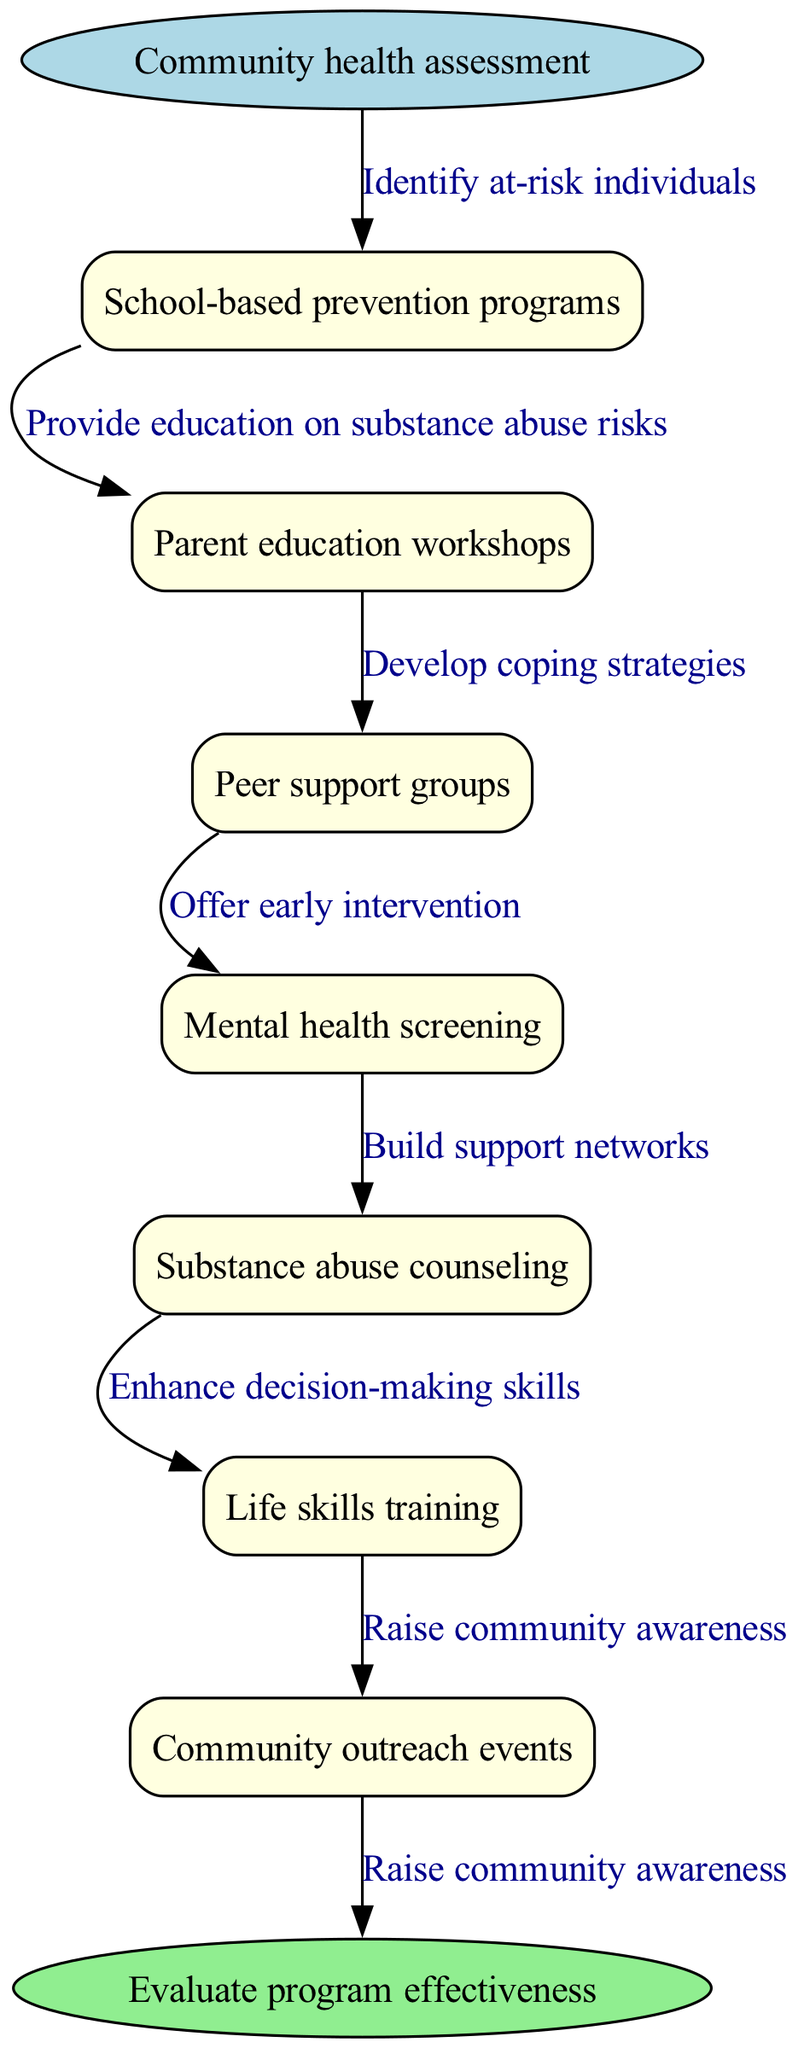What is the starting point of the clinical pathway? The starting point is explicitly mentioned as "Community health assessment" in the diagram.
Answer: Community health assessment How many nodes are in the diagram? There are 7 nodes listed under the "nodes" key in the data, representing various program components.
Answer: 7 What is the end point of the pathway? The end point is clearly labeled as "Evaluate program effectiveness" in the diagram, summarizing the outcome of the pathway.
Answer: Evaluate program effectiveness Which node is connected to the first edge? The first edge connects the starting point to the first node, which is "School-based prevention programs" according to the listed nodes.
Answer: School-based prevention programs What type of workshops are included in the nodes? The type of workshops mentioned in the nodes is "Parent education workshops," indicating the focus on engaging parents in education efforts.
Answer: Parent education workshops How many edges are in the diagram? By counting the connections listed under "edges," we can determine there are 7 edges representing the relationships between nodes and the starting point.
Answer: 7 What does the second edge represent? The second edge explicitly describes a connection from the starting point to the first node, representing the action "Provide education on substance abuse risks."
Answer: Provide education on substance abuse risks Which node follows "Peer support groups"? The node that follows "Peer support groups" in the sequence is "Mental health screening," indicating a progression in the pathway.
Answer: Mental health screening What is the primary goal of the entire clinical pathway? The primary goal is represented by the end point, which focuses on effectively evaluating the program's outcomes and impact in the community.
Answer: Evaluate program effectiveness 